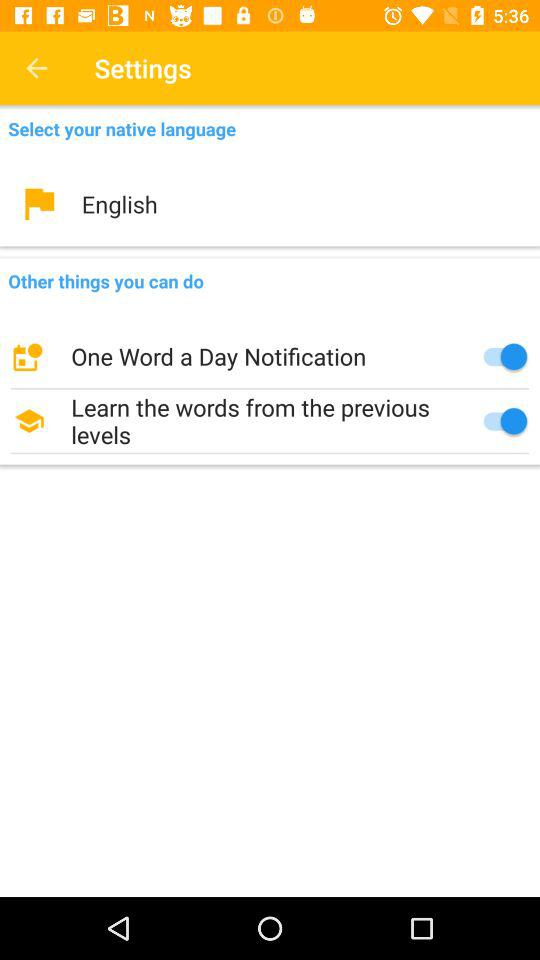Which native language is selected? The selected native language is English. 